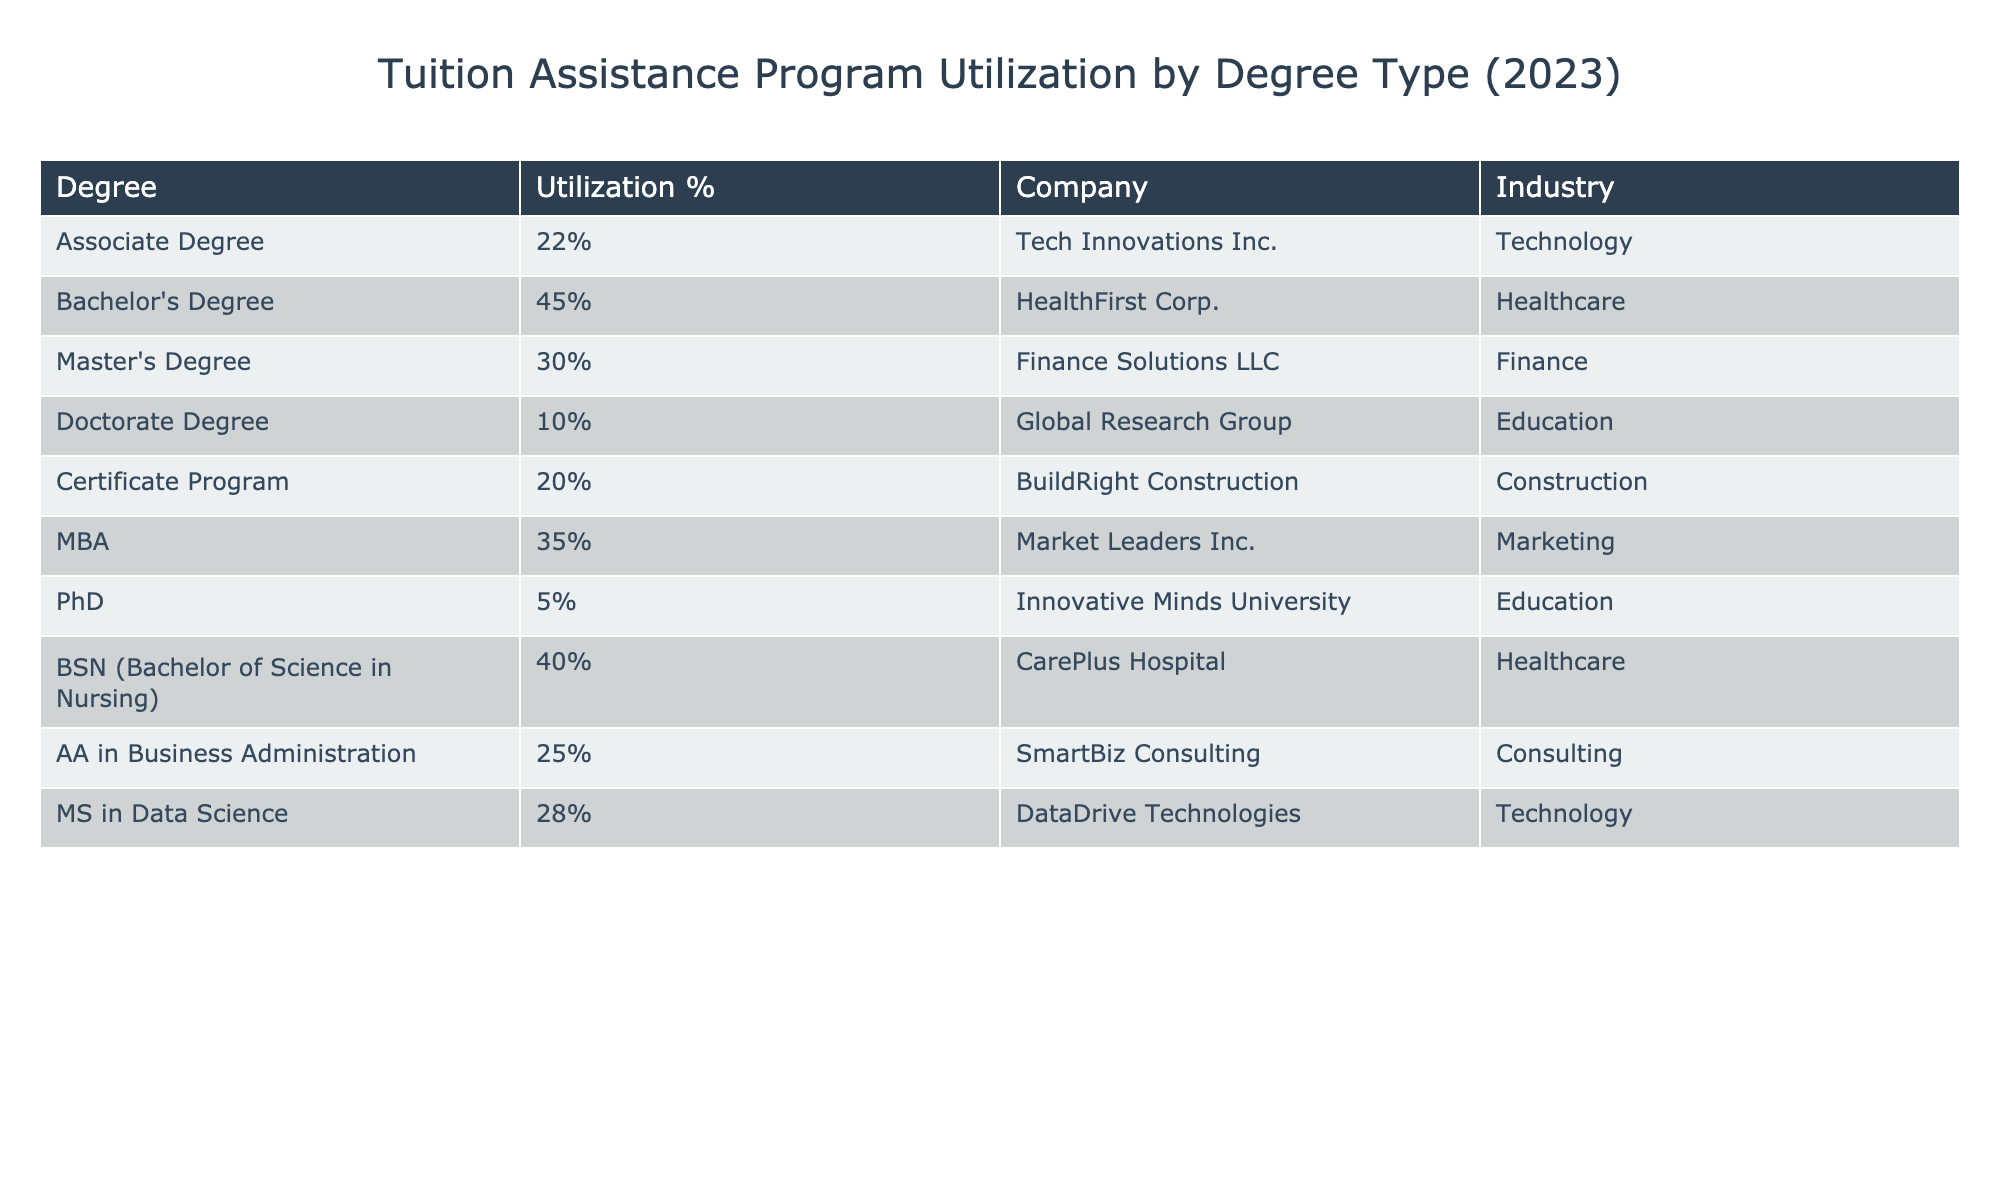What is the percentage of employees utilizing tuition assistance for a Master's Degree? The table shows the percentage for a Master's Degree listed as 30%.
Answer: 30% Which degree type has the highest percentage of employees utilizing tuition assistance? By comparing the percentages, the Bachelor's Degree has the highest percentage at 45%.
Answer: Bachelor's Degree What is the percentage difference between employees utilizing tuition assistance for an MBA and a PhD? The MBA percentage is 35% and the PhD percentage is 5%. The difference is 35% - 5% = 30%.
Answer: 30% Is the percentage of employees utilizing tuition assistance for a Certificate Program greater than that for a Doctorate Degree? The Certificate Program has a utilization percentage of 20%, while the Doctorate Degree has a percentage of 10%, making the Certificate Program greater.
Answer: Yes What is the average percentage of employees utilizing tuition assistance across all degree types listed in the table? To find the average, sum the percentages: (22 + 45 + 30 + 10 + 20 + 35 + 5 + 40 + 25 + 28) =  8 and then divide by the number of degree types (10), thus average is 22%.
Answer: 22% How many degree types have a utilization percentage of 30% or higher? The degree types with 30% or higher are Bachelor's Degree (45%), MBA (35%), BSN (40%), and Master’s Degree (30%), totaling four degree types.
Answer: 4 Which company has the lowest percentage of employees utilizing tuition assistance? The table indicates the company with the lowest percentage is Innovative Minds University, with a PhD utilization of 5%.
Answer: Innovative Minds University If we consider only the healthcare industry, what is the percentage of employees utilizing tuition assistance? In the healthcare industry, there are two entries: HealthFirst Corp. with a Bachelor's Degree at 45% and CarePlus Hospital with a BSN at 40%. Therefore, the average is (45% + 40%) / 2 = 42.5%.
Answer: 42.5% What percentage of employees in the technology industry utilize tuition assistance for an Associate Degree? The table lists Tech Innovations Inc. under the technology industry with an Associate Degree utilization percentage of 22%.
Answer: 22% Is there a degree type where less than 20% of employees utilize tuition assistance? The lowest percentage indicated in the table is for the PhD, which is 5%, so yes, there is a degree type below 20%.
Answer: Yes 